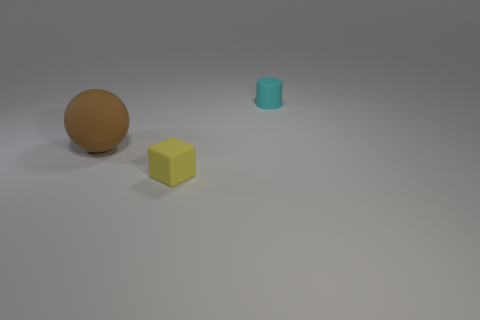Add 1 cyan things. How many objects exist? 4 Subtract all balls. How many objects are left? 2 Subtract all yellow matte spheres. Subtract all cyan objects. How many objects are left? 2 Add 2 small objects. How many small objects are left? 4 Add 1 small cyan metal things. How many small cyan metal things exist? 1 Subtract 0 yellow spheres. How many objects are left? 3 